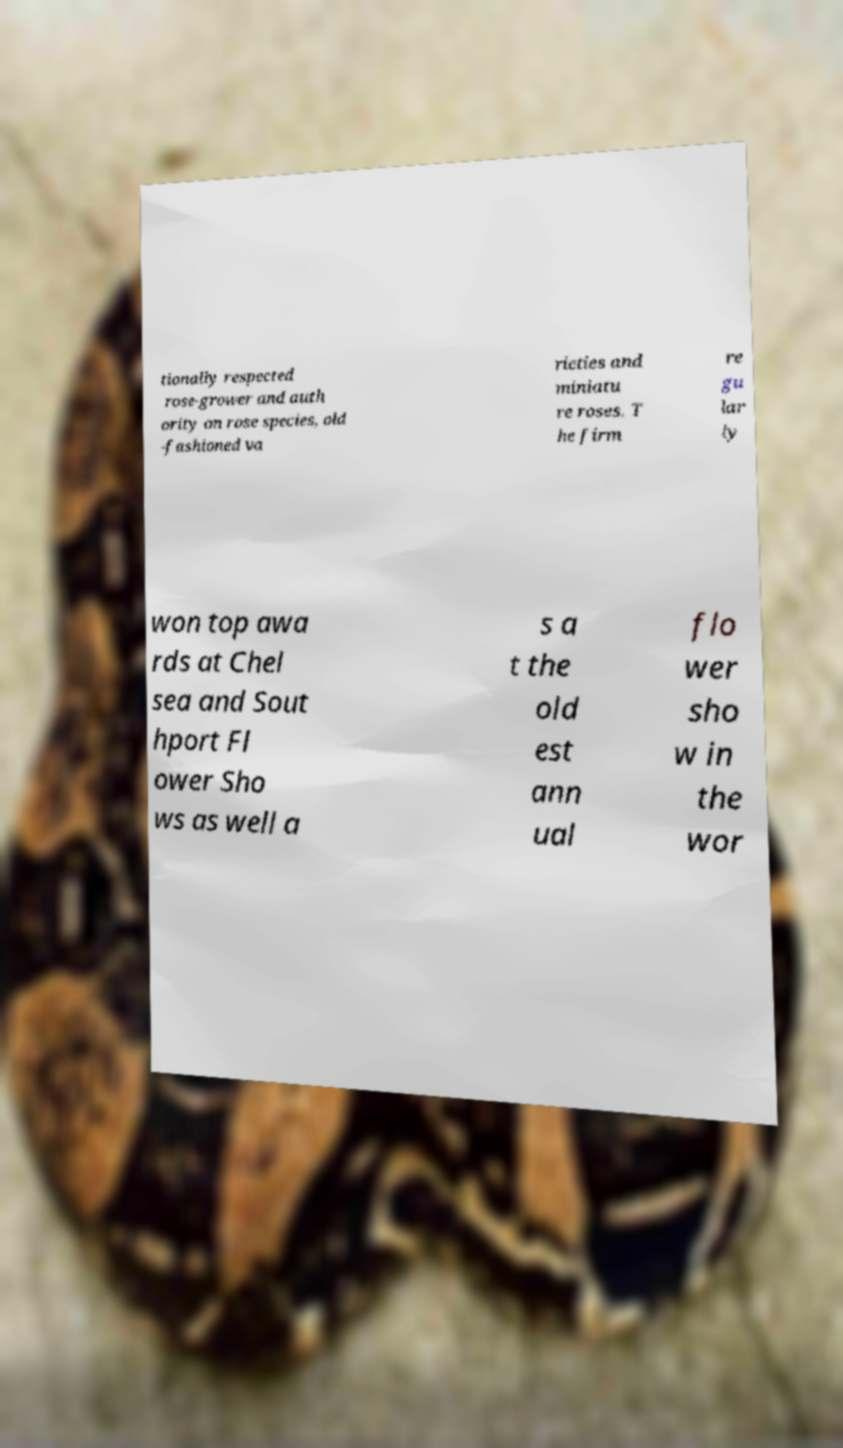Please read and relay the text visible in this image. What does it say? tionally respected rose-grower and auth ority on rose species, old -fashioned va rieties and miniatu re roses. T he firm re gu lar ly won top awa rds at Chel sea and Sout hport Fl ower Sho ws as well a s a t the old est ann ual flo wer sho w in the wor 